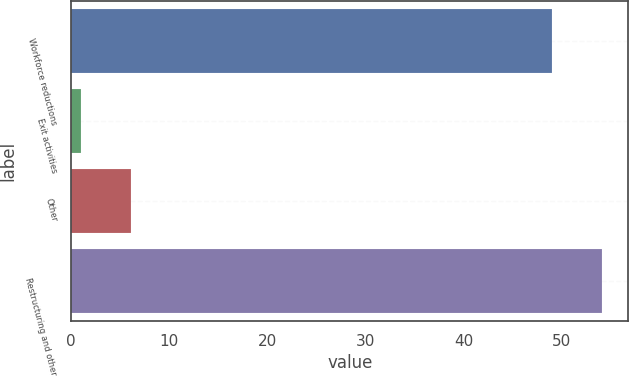Convert chart. <chart><loc_0><loc_0><loc_500><loc_500><bar_chart><fcel>Workforce reductions<fcel>Exit activities<fcel>Other<fcel>Restructuring and other<nl><fcel>49<fcel>1<fcel>6.1<fcel>54.1<nl></chart> 